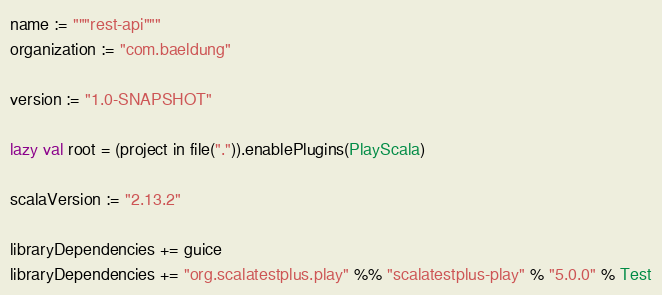Convert code to text. <code><loc_0><loc_0><loc_500><loc_500><_Scala_>name := """rest-api"""
organization := "com.baeldung"

version := "1.0-SNAPSHOT"

lazy val root = (project in file(".")).enablePlugins(PlayScala)

scalaVersion := "2.13.2"

libraryDependencies += guice
libraryDependencies += "org.scalatestplus.play" %% "scalatestplus-play" % "5.0.0" % Test
</code> 